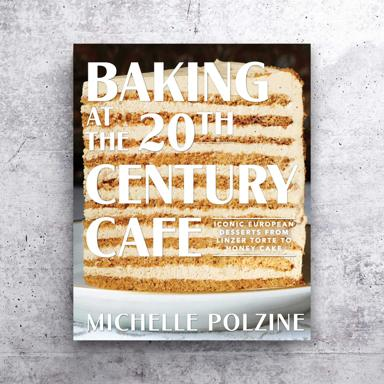Which European countries are most influencial in the recipes included in this book? The recipes in this book are heavily influenced by the dessert traditions of Central and Eastern European countries. Expect to explore flavors and techniques from Austria, Hungary, Czech Republic, and beyond. These regions are celebrated for their rich dessert heritage, which includes everything from Viennese sachertorte to Hungarian dobos torte. 